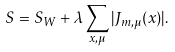<formula> <loc_0><loc_0><loc_500><loc_500>S = S _ { W } + \lambda \sum _ { x , \mu } | J _ { m , \mu } ( x ) | .</formula> 